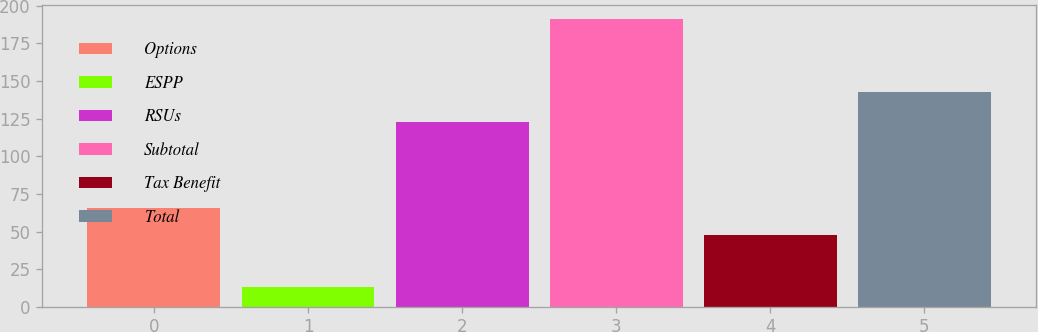<chart> <loc_0><loc_0><loc_500><loc_500><bar_chart><fcel>Options<fcel>ESPP<fcel>RSUs<fcel>Subtotal<fcel>Tax Benefit<fcel>Total<nl><fcel>65.8<fcel>13<fcel>123<fcel>191<fcel>48<fcel>143<nl></chart> 